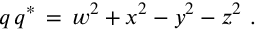<formula> <loc_0><loc_0><loc_500><loc_500>q \, q ^ { * } \, = \, w ^ { 2 } + x ^ { 2 } - y ^ { 2 } - z ^ { 2 } .</formula> 